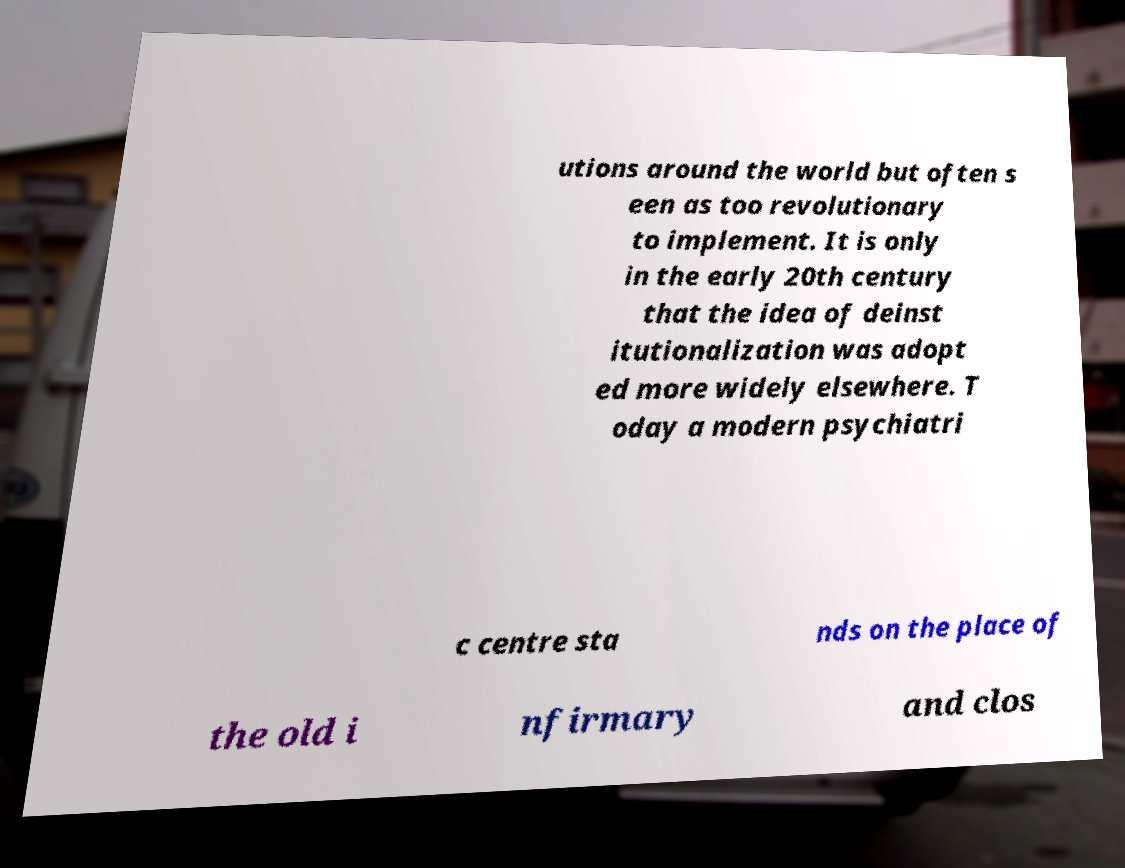Can you accurately transcribe the text from the provided image for me? utions around the world but often s een as too revolutionary to implement. It is only in the early 20th century that the idea of deinst itutionalization was adopt ed more widely elsewhere. T oday a modern psychiatri c centre sta nds on the place of the old i nfirmary and clos 